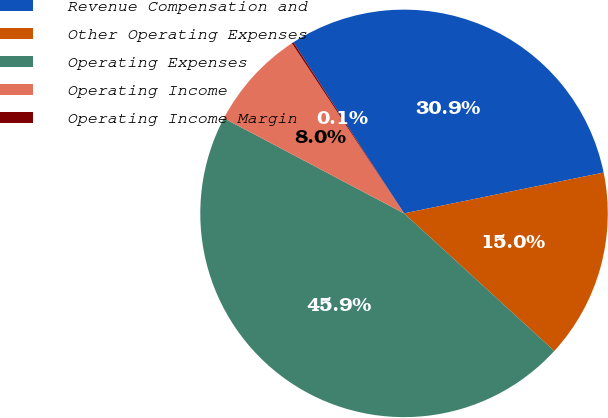Convert chart. <chart><loc_0><loc_0><loc_500><loc_500><pie_chart><fcel>Revenue Compensation and<fcel>Other Operating Expenses<fcel>Operating Expenses<fcel>Operating Income<fcel>Operating Income Margin<nl><fcel>30.92%<fcel>15.01%<fcel>45.93%<fcel>7.99%<fcel>0.14%<nl></chart> 